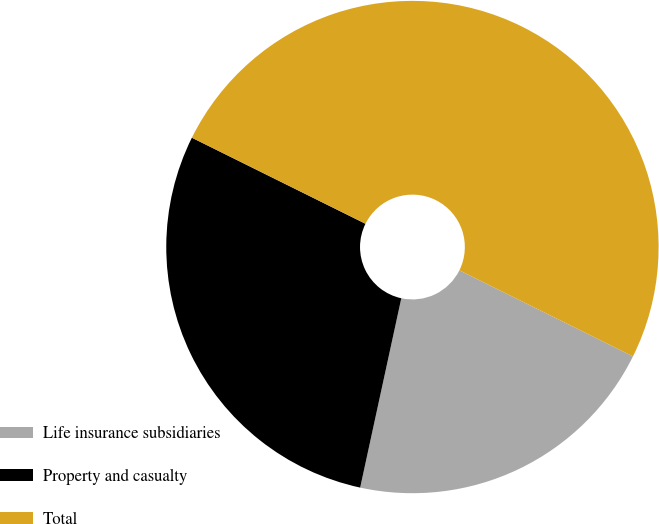Convert chart to OTSL. <chart><loc_0><loc_0><loc_500><loc_500><pie_chart><fcel>Life insurance subsidiaries<fcel>Property and casualty<fcel>Total<nl><fcel>21.08%<fcel>28.92%<fcel>50.0%<nl></chart> 